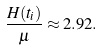<formula> <loc_0><loc_0><loc_500><loc_500>\frac { H ( t _ { i } ) } { \mu } \approx 2 . 9 2 .</formula> 